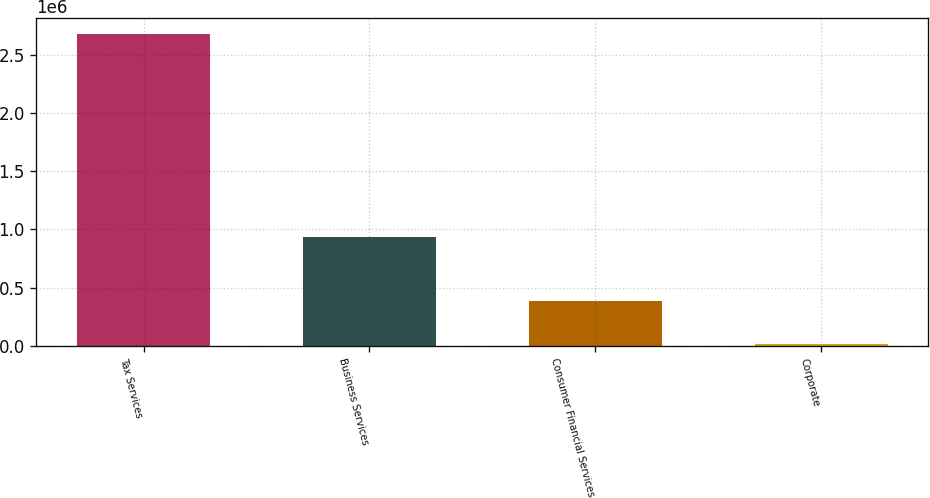<chart> <loc_0><loc_0><loc_500><loc_500><bar_chart><fcel>Tax Services<fcel>Business Services<fcel>Consumer Financial Services<fcel>Corporate<nl><fcel>2.68586e+06<fcel>932361<fcel>388090<fcel>14965<nl></chart> 